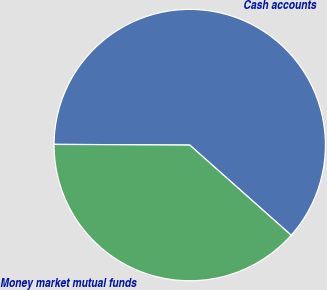Convert chart to OTSL. <chart><loc_0><loc_0><loc_500><loc_500><pie_chart><fcel>Cash accounts<fcel>Money market mutual funds<nl><fcel>61.48%<fcel>38.52%<nl></chart> 